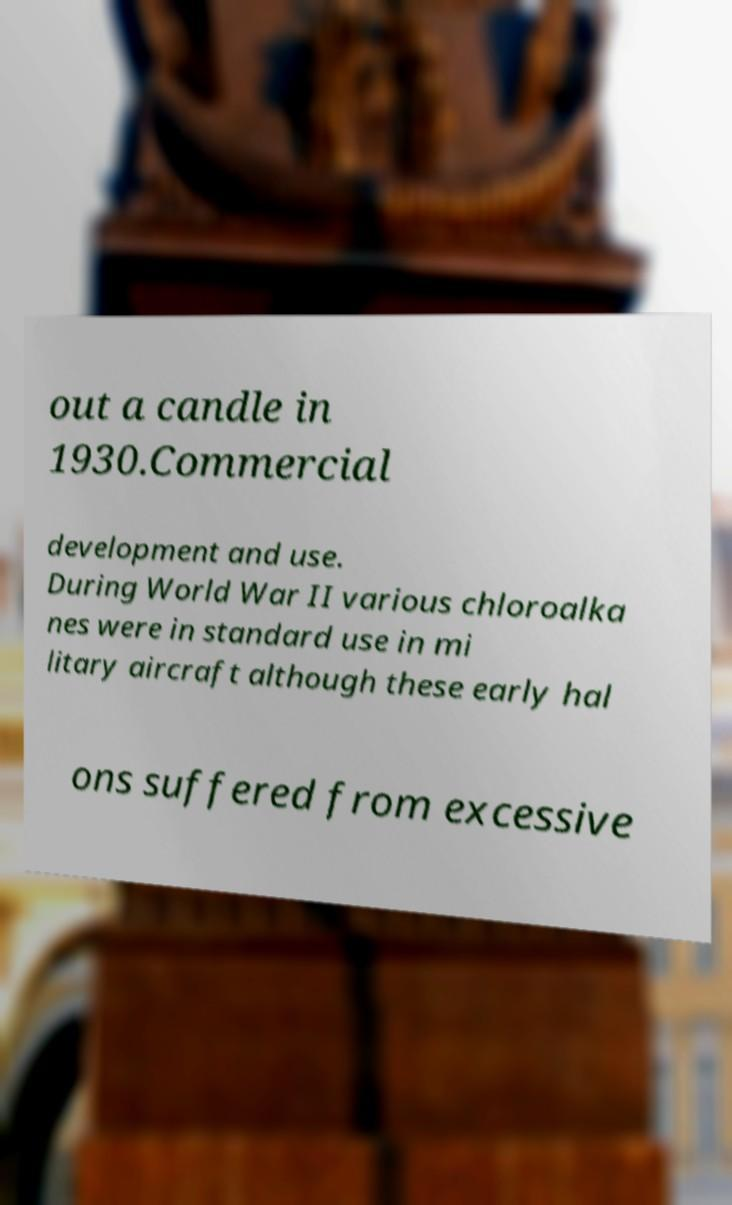Please identify and transcribe the text found in this image. out a candle in 1930.Commercial development and use. During World War II various chloroalka nes were in standard use in mi litary aircraft although these early hal ons suffered from excessive 